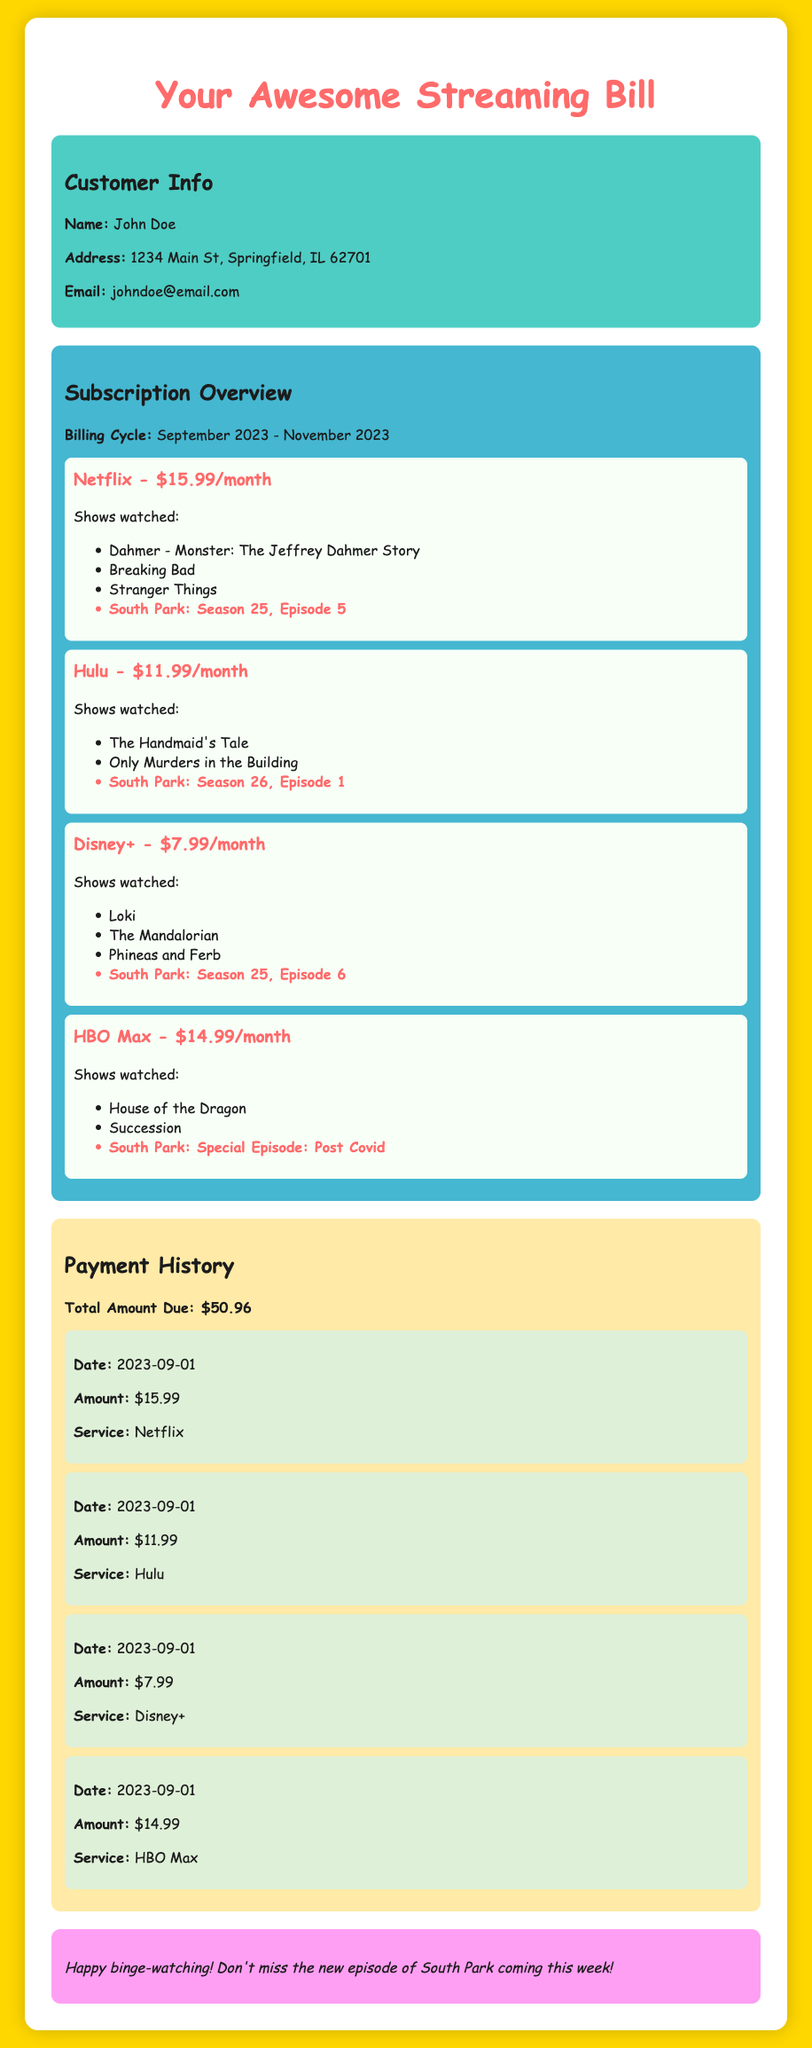What is the customer's name? The customer's name is provided in the customer info section of the document.
Answer: John Doe What is the billing cycle? The billing cycle indicates the duration for the billing period, found in the subscription overview.
Answer: September 2023 - November 2023 How much is the subscription fee for Disney+? The subscription fee for each service is listed under the subscription overview section.
Answer: $7.99/month Which episode of South Park was watched on Hulu? The watched shows for each service include South Park episodes, which can be found in the service section for Hulu.
Answer: Season 26, Episode 1 How many services are listed in the subscription overview? The count of services is inferred from the number of service sections in the subscription overview.
Answer: 4 What is the total amount due? The total amount due is summarized in the payment history section.
Answer: $50.96 On what date was the payment for HBO Max made? The payment date for each service payment is provided in the payment history section.
Answer: 2023-09-01 What show is highlighted in the payment history? The document highlights shows, with the specific highlight color indicating South Park shows.
Answer: South Park: Special Episode: Post Covid What is the background color of the customer info section? The background color of each section is defined in the style of the document.
Answer: #4ecdc4 